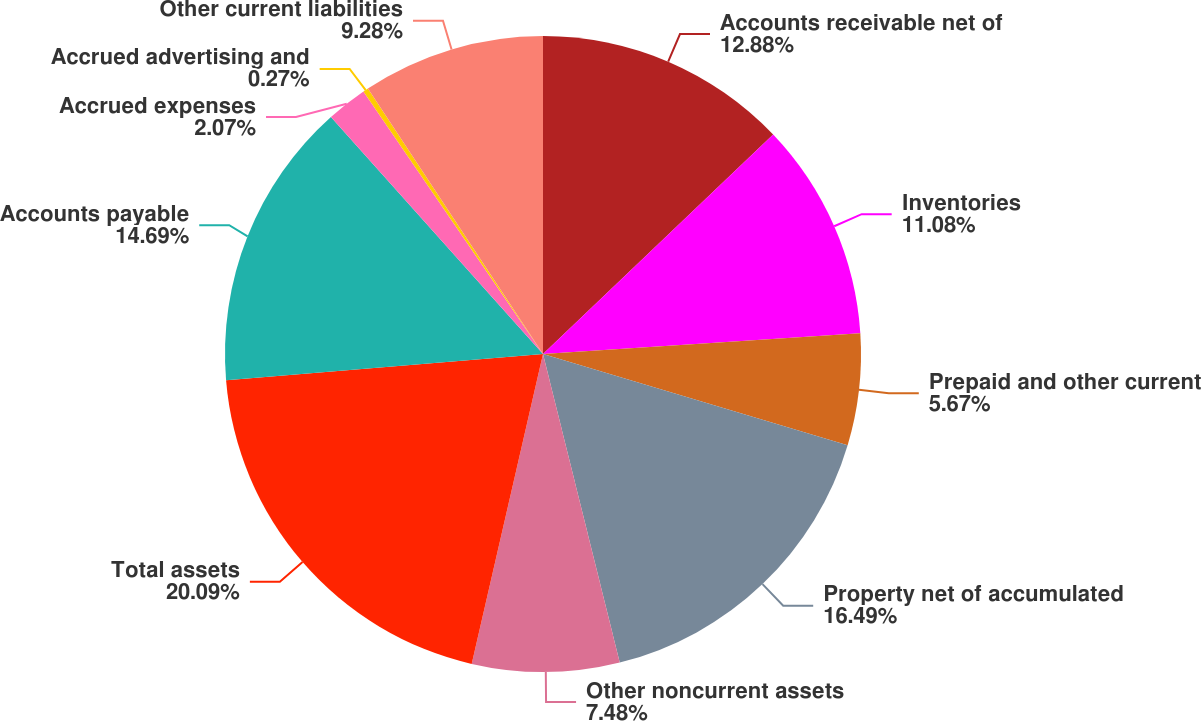Convert chart to OTSL. <chart><loc_0><loc_0><loc_500><loc_500><pie_chart><fcel>Accounts receivable net of<fcel>Inventories<fcel>Prepaid and other current<fcel>Property net of accumulated<fcel>Other noncurrent assets<fcel>Total assets<fcel>Accounts payable<fcel>Accrued expenses<fcel>Accrued advertising and<fcel>Other current liabilities<nl><fcel>12.88%<fcel>11.08%<fcel>5.67%<fcel>16.49%<fcel>7.48%<fcel>20.09%<fcel>14.69%<fcel>2.07%<fcel>0.27%<fcel>9.28%<nl></chart> 